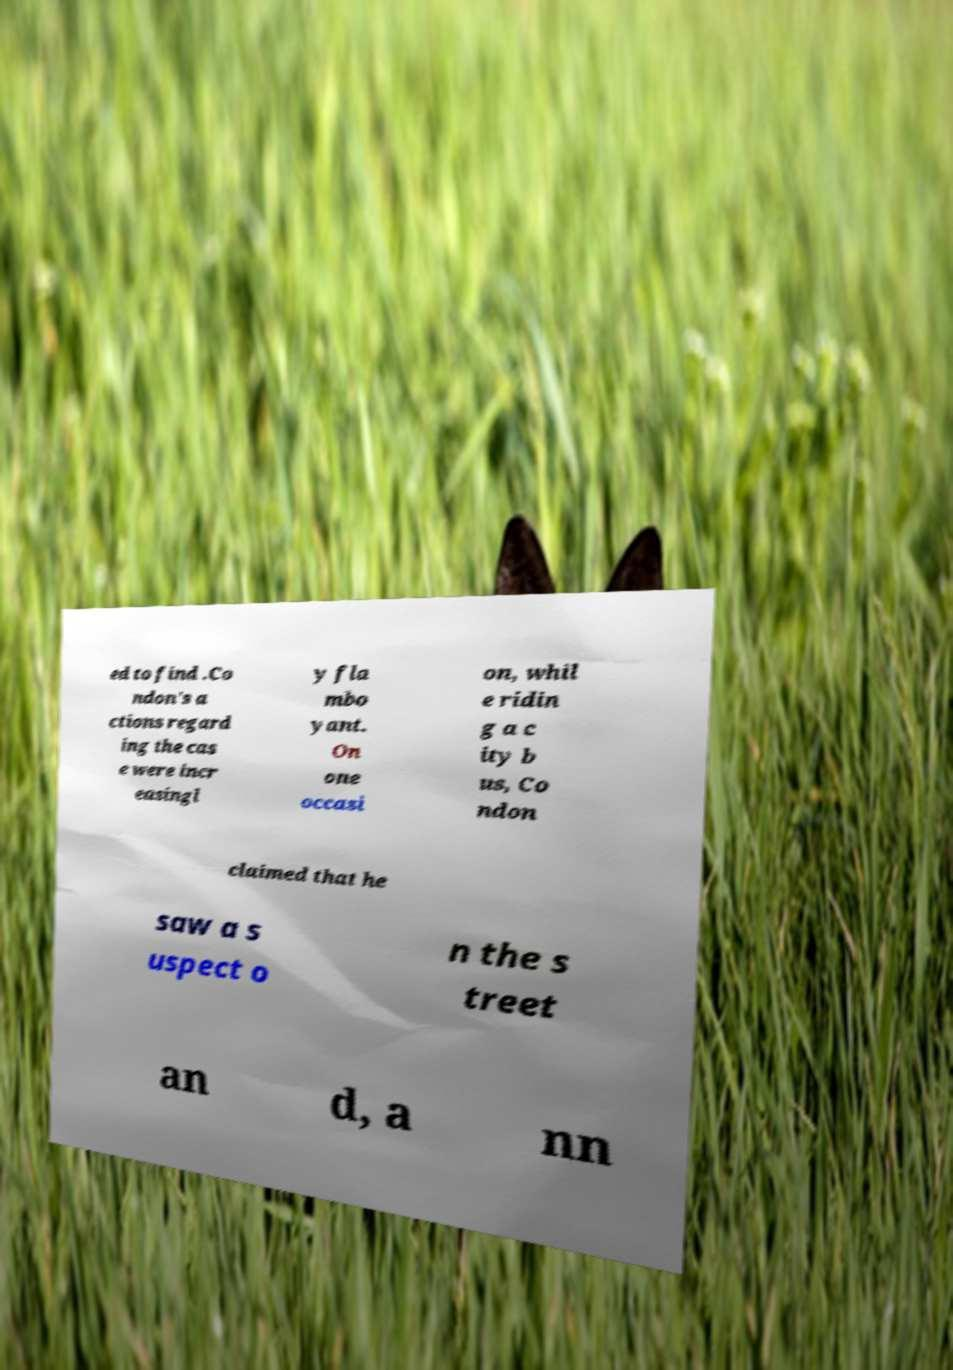Please identify and transcribe the text found in this image. ed to find .Co ndon's a ctions regard ing the cas e were incr easingl y fla mbo yant. On one occasi on, whil e ridin g a c ity b us, Co ndon claimed that he saw a s uspect o n the s treet an d, a nn 